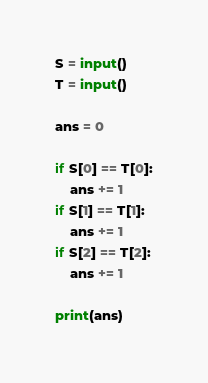Convert code to text. <code><loc_0><loc_0><loc_500><loc_500><_Python_>S = input()
T = input()

ans = 0

if S[0] == T[0]:
    ans += 1
if S[1] == T[1]:
    ans += 1
if S[2] == T[2]:
    ans += 1

print(ans)</code> 